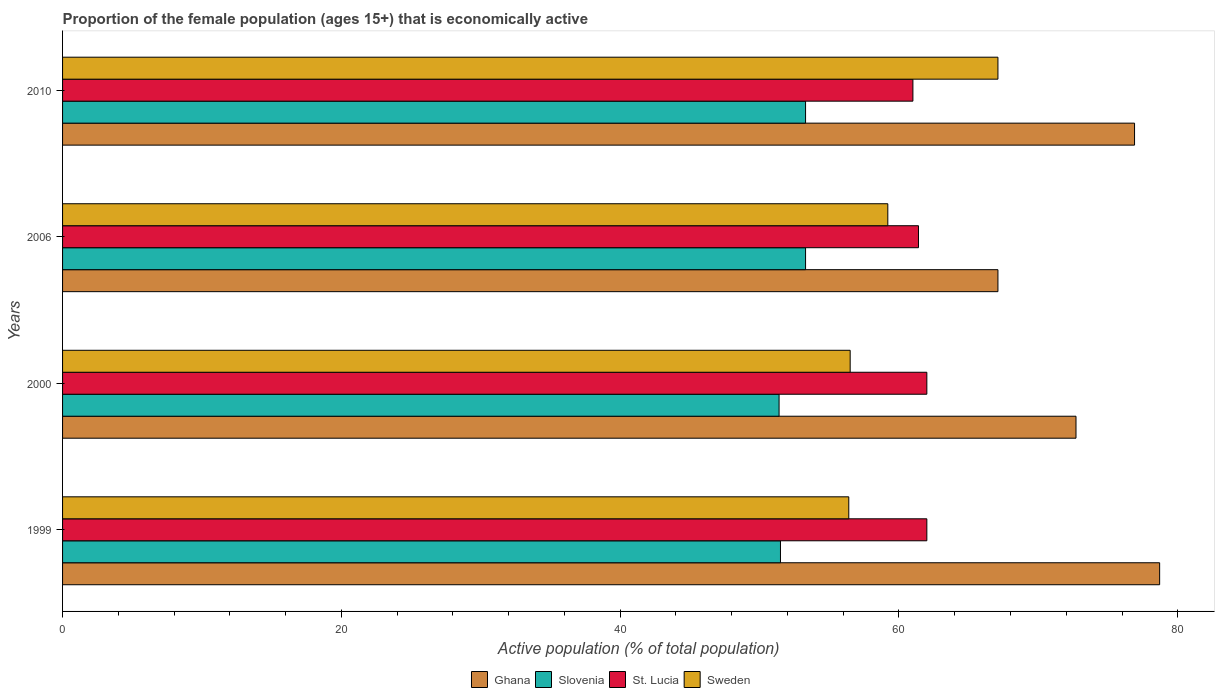How many different coloured bars are there?
Your answer should be very brief. 4. How many groups of bars are there?
Keep it short and to the point. 4. How many bars are there on the 1st tick from the top?
Your answer should be compact. 4. Across all years, what is the maximum proportion of the female population that is economically active in Sweden?
Your answer should be very brief. 67.1. Across all years, what is the minimum proportion of the female population that is economically active in Sweden?
Provide a short and direct response. 56.4. In which year was the proportion of the female population that is economically active in Sweden maximum?
Make the answer very short. 2010. In which year was the proportion of the female population that is economically active in Sweden minimum?
Offer a terse response. 1999. What is the total proportion of the female population that is economically active in Ghana in the graph?
Make the answer very short. 295.4. What is the difference between the proportion of the female population that is economically active in Slovenia in 2000 and that in 2010?
Your answer should be very brief. -1.9. What is the difference between the proportion of the female population that is economically active in St. Lucia in 2010 and the proportion of the female population that is economically active in Slovenia in 2000?
Your answer should be compact. 9.6. What is the average proportion of the female population that is economically active in St. Lucia per year?
Offer a very short reply. 61.6. In the year 2006, what is the difference between the proportion of the female population that is economically active in Sweden and proportion of the female population that is economically active in Ghana?
Provide a short and direct response. -7.9. In how many years, is the proportion of the female population that is economically active in Sweden greater than 36 %?
Make the answer very short. 4. What is the ratio of the proportion of the female population that is economically active in Slovenia in 1999 to that in 2000?
Your answer should be compact. 1. Is the proportion of the female population that is economically active in Sweden in 1999 less than that in 2000?
Offer a very short reply. Yes. What is the difference between the highest and the second highest proportion of the female population that is economically active in Slovenia?
Provide a short and direct response. 0. What is the difference between the highest and the lowest proportion of the female population that is economically active in Sweden?
Give a very brief answer. 10.7. In how many years, is the proportion of the female population that is economically active in Sweden greater than the average proportion of the female population that is economically active in Sweden taken over all years?
Your response must be concise. 1. Is it the case that in every year, the sum of the proportion of the female population that is economically active in Sweden and proportion of the female population that is economically active in Slovenia is greater than the sum of proportion of the female population that is economically active in St. Lucia and proportion of the female population that is economically active in Ghana?
Your response must be concise. No. What does the 2nd bar from the bottom in 2006 represents?
Your response must be concise. Slovenia. Are all the bars in the graph horizontal?
Ensure brevity in your answer.  Yes. How many years are there in the graph?
Your response must be concise. 4. What is the difference between two consecutive major ticks on the X-axis?
Offer a very short reply. 20. Are the values on the major ticks of X-axis written in scientific E-notation?
Your answer should be very brief. No. Does the graph contain grids?
Your response must be concise. No. Where does the legend appear in the graph?
Your response must be concise. Bottom center. How many legend labels are there?
Offer a terse response. 4. What is the title of the graph?
Make the answer very short. Proportion of the female population (ages 15+) that is economically active. Does "Macao" appear as one of the legend labels in the graph?
Offer a very short reply. No. What is the label or title of the X-axis?
Your answer should be compact. Active population (% of total population). What is the Active population (% of total population) in Ghana in 1999?
Ensure brevity in your answer.  78.7. What is the Active population (% of total population) in Slovenia in 1999?
Your response must be concise. 51.5. What is the Active population (% of total population) in St. Lucia in 1999?
Offer a terse response. 62. What is the Active population (% of total population) of Sweden in 1999?
Keep it short and to the point. 56.4. What is the Active population (% of total population) of Ghana in 2000?
Offer a terse response. 72.7. What is the Active population (% of total population) of Slovenia in 2000?
Make the answer very short. 51.4. What is the Active population (% of total population) in St. Lucia in 2000?
Make the answer very short. 62. What is the Active population (% of total population) of Sweden in 2000?
Provide a short and direct response. 56.5. What is the Active population (% of total population) in Ghana in 2006?
Give a very brief answer. 67.1. What is the Active population (% of total population) of Slovenia in 2006?
Your answer should be very brief. 53.3. What is the Active population (% of total population) in St. Lucia in 2006?
Offer a terse response. 61.4. What is the Active population (% of total population) of Sweden in 2006?
Your answer should be compact. 59.2. What is the Active population (% of total population) of Ghana in 2010?
Make the answer very short. 76.9. What is the Active population (% of total population) in Slovenia in 2010?
Ensure brevity in your answer.  53.3. What is the Active population (% of total population) in Sweden in 2010?
Offer a terse response. 67.1. Across all years, what is the maximum Active population (% of total population) of Ghana?
Your answer should be compact. 78.7. Across all years, what is the maximum Active population (% of total population) of Slovenia?
Provide a short and direct response. 53.3. Across all years, what is the maximum Active population (% of total population) of St. Lucia?
Make the answer very short. 62. Across all years, what is the maximum Active population (% of total population) of Sweden?
Give a very brief answer. 67.1. Across all years, what is the minimum Active population (% of total population) of Ghana?
Provide a succinct answer. 67.1. Across all years, what is the minimum Active population (% of total population) of Slovenia?
Your answer should be compact. 51.4. Across all years, what is the minimum Active population (% of total population) in St. Lucia?
Your response must be concise. 61. Across all years, what is the minimum Active population (% of total population) of Sweden?
Make the answer very short. 56.4. What is the total Active population (% of total population) in Ghana in the graph?
Offer a very short reply. 295.4. What is the total Active population (% of total population) of Slovenia in the graph?
Ensure brevity in your answer.  209.5. What is the total Active population (% of total population) of St. Lucia in the graph?
Make the answer very short. 246.4. What is the total Active population (% of total population) in Sweden in the graph?
Give a very brief answer. 239.2. What is the difference between the Active population (% of total population) in Ghana in 1999 and that in 2000?
Provide a succinct answer. 6. What is the difference between the Active population (% of total population) in Sweden in 1999 and that in 2000?
Provide a succinct answer. -0.1. What is the difference between the Active population (% of total population) of Sweden in 1999 and that in 2006?
Make the answer very short. -2.8. What is the difference between the Active population (% of total population) in Ghana in 1999 and that in 2010?
Your answer should be very brief. 1.8. What is the difference between the Active population (% of total population) in Slovenia in 1999 and that in 2010?
Offer a very short reply. -1.8. What is the difference between the Active population (% of total population) of Sweden in 1999 and that in 2010?
Make the answer very short. -10.7. What is the difference between the Active population (% of total population) of Slovenia in 2000 and that in 2006?
Your answer should be compact. -1.9. What is the difference between the Active population (% of total population) in Sweden in 2000 and that in 2006?
Provide a short and direct response. -2.7. What is the difference between the Active population (% of total population) of Slovenia in 2000 and that in 2010?
Keep it short and to the point. -1.9. What is the difference between the Active population (% of total population) of Ghana in 2006 and that in 2010?
Your response must be concise. -9.8. What is the difference between the Active population (% of total population) in Slovenia in 2006 and that in 2010?
Keep it short and to the point. 0. What is the difference between the Active population (% of total population) in Ghana in 1999 and the Active population (% of total population) in Slovenia in 2000?
Provide a short and direct response. 27.3. What is the difference between the Active population (% of total population) in Slovenia in 1999 and the Active population (% of total population) in St. Lucia in 2000?
Keep it short and to the point. -10.5. What is the difference between the Active population (% of total population) of Ghana in 1999 and the Active population (% of total population) of Slovenia in 2006?
Make the answer very short. 25.4. What is the difference between the Active population (% of total population) of Ghana in 1999 and the Active population (% of total population) of St. Lucia in 2006?
Keep it short and to the point. 17.3. What is the difference between the Active population (% of total population) in Ghana in 1999 and the Active population (% of total population) in Sweden in 2006?
Your answer should be compact. 19.5. What is the difference between the Active population (% of total population) in Ghana in 1999 and the Active population (% of total population) in Slovenia in 2010?
Provide a short and direct response. 25.4. What is the difference between the Active population (% of total population) in Ghana in 1999 and the Active population (% of total population) in St. Lucia in 2010?
Offer a very short reply. 17.7. What is the difference between the Active population (% of total population) in Slovenia in 1999 and the Active population (% of total population) in St. Lucia in 2010?
Ensure brevity in your answer.  -9.5. What is the difference between the Active population (% of total population) in Slovenia in 1999 and the Active population (% of total population) in Sweden in 2010?
Provide a short and direct response. -15.6. What is the difference between the Active population (% of total population) in St. Lucia in 1999 and the Active population (% of total population) in Sweden in 2010?
Your answer should be compact. -5.1. What is the difference between the Active population (% of total population) in Ghana in 2000 and the Active population (% of total population) in Sweden in 2006?
Make the answer very short. 13.5. What is the difference between the Active population (% of total population) of Slovenia in 2000 and the Active population (% of total population) of St. Lucia in 2010?
Offer a very short reply. -9.6. What is the difference between the Active population (% of total population) of Slovenia in 2000 and the Active population (% of total population) of Sweden in 2010?
Your answer should be very brief. -15.7. What is the difference between the Active population (% of total population) in Ghana in 2006 and the Active population (% of total population) in Slovenia in 2010?
Your answer should be compact. 13.8. What is the difference between the Active population (% of total population) in Ghana in 2006 and the Active population (% of total population) in St. Lucia in 2010?
Provide a short and direct response. 6.1. What is the difference between the Active population (% of total population) in Ghana in 2006 and the Active population (% of total population) in Sweden in 2010?
Make the answer very short. 0. What is the difference between the Active population (% of total population) in Slovenia in 2006 and the Active population (% of total population) in St. Lucia in 2010?
Ensure brevity in your answer.  -7.7. What is the average Active population (% of total population) in Ghana per year?
Make the answer very short. 73.85. What is the average Active population (% of total population) of Slovenia per year?
Provide a short and direct response. 52.38. What is the average Active population (% of total population) in St. Lucia per year?
Your answer should be compact. 61.6. What is the average Active population (% of total population) in Sweden per year?
Offer a very short reply. 59.8. In the year 1999, what is the difference between the Active population (% of total population) of Ghana and Active population (% of total population) of Slovenia?
Ensure brevity in your answer.  27.2. In the year 1999, what is the difference between the Active population (% of total population) in Ghana and Active population (% of total population) in St. Lucia?
Provide a succinct answer. 16.7. In the year 1999, what is the difference between the Active population (% of total population) in Ghana and Active population (% of total population) in Sweden?
Offer a terse response. 22.3. In the year 1999, what is the difference between the Active population (% of total population) of Slovenia and Active population (% of total population) of Sweden?
Your answer should be very brief. -4.9. In the year 2000, what is the difference between the Active population (% of total population) of Ghana and Active population (% of total population) of Slovenia?
Your response must be concise. 21.3. In the year 2000, what is the difference between the Active population (% of total population) of Ghana and Active population (% of total population) of St. Lucia?
Your answer should be very brief. 10.7. In the year 2000, what is the difference between the Active population (% of total population) in Ghana and Active population (% of total population) in Sweden?
Ensure brevity in your answer.  16.2. In the year 2000, what is the difference between the Active population (% of total population) in St. Lucia and Active population (% of total population) in Sweden?
Offer a very short reply. 5.5. In the year 2006, what is the difference between the Active population (% of total population) of Ghana and Active population (% of total population) of Slovenia?
Your answer should be compact. 13.8. In the year 2006, what is the difference between the Active population (% of total population) of Ghana and Active population (% of total population) of St. Lucia?
Your answer should be very brief. 5.7. In the year 2006, what is the difference between the Active population (% of total population) of Ghana and Active population (% of total population) of Sweden?
Your answer should be very brief. 7.9. In the year 2006, what is the difference between the Active population (% of total population) in Slovenia and Active population (% of total population) in St. Lucia?
Provide a succinct answer. -8.1. In the year 2006, what is the difference between the Active population (% of total population) in Slovenia and Active population (% of total population) in Sweden?
Your answer should be very brief. -5.9. In the year 2006, what is the difference between the Active population (% of total population) in St. Lucia and Active population (% of total population) in Sweden?
Make the answer very short. 2.2. In the year 2010, what is the difference between the Active population (% of total population) in Ghana and Active population (% of total population) in Slovenia?
Your answer should be compact. 23.6. In the year 2010, what is the difference between the Active population (% of total population) in Ghana and Active population (% of total population) in St. Lucia?
Ensure brevity in your answer.  15.9. In the year 2010, what is the difference between the Active population (% of total population) in Slovenia and Active population (% of total population) in St. Lucia?
Make the answer very short. -7.7. In the year 2010, what is the difference between the Active population (% of total population) of Slovenia and Active population (% of total population) of Sweden?
Offer a terse response. -13.8. What is the ratio of the Active population (% of total population) of Ghana in 1999 to that in 2000?
Your response must be concise. 1.08. What is the ratio of the Active population (% of total population) in Sweden in 1999 to that in 2000?
Offer a terse response. 1. What is the ratio of the Active population (% of total population) of Ghana in 1999 to that in 2006?
Give a very brief answer. 1.17. What is the ratio of the Active population (% of total population) in Slovenia in 1999 to that in 2006?
Your answer should be very brief. 0.97. What is the ratio of the Active population (% of total population) of St. Lucia in 1999 to that in 2006?
Make the answer very short. 1.01. What is the ratio of the Active population (% of total population) of Sweden in 1999 to that in 2006?
Your response must be concise. 0.95. What is the ratio of the Active population (% of total population) of Ghana in 1999 to that in 2010?
Offer a terse response. 1.02. What is the ratio of the Active population (% of total population) of Slovenia in 1999 to that in 2010?
Your response must be concise. 0.97. What is the ratio of the Active population (% of total population) in St. Lucia in 1999 to that in 2010?
Your response must be concise. 1.02. What is the ratio of the Active population (% of total population) of Sweden in 1999 to that in 2010?
Your answer should be compact. 0.84. What is the ratio of the Active population (% of total population) of Ghana in 2000 to that in 2006?
Make the answer very short. 1.08. What is the ratio of the Active population (% of total population) in Slovenia in 2000 to that in 2006?
Your answer should be compact. 0.96. What is the ratio of the Active population (% of total population) of St. Lucia in 2000 to that in 2006?
Your response must be concise. 1.01. What is the ratio of the Active population (% of total population) in Sweden in 2000 to that in 2006?
Offer a terse response. 0.95. What is the ratio of the Active population (% of total population) in Ghana in 2000 to that in 2010?
Keep it short and to the point. 0.95. What is the ratio of the Active population (% of total population) in Slovenia in 2000 to that in 2010?
Offer a very short reply. 0.96. What is the ratio of the Active population (% of total population) of St. Lucia in 2000 to that in 2010?
Your answer should be very brief. 1.02. What is the ratio of the Active population (% of total population) of Sweden in 2000 to that in 2010?
Your response must be concise. 0.84. What is the ratio of the Active population (% of total population) in Ghana in 2006 to that in 2010?
Keep it short and to the point. 0.87. What is the ratio of the Active population (% of total population) of Slovenia in 2006 to that in 2010?
Ensure brevity in your answer.  1. What is the ratio of the Active population (% of total population) in St. Lucia in 2006 to that in 2010?
Keep it short and to the point. 1.01. What is the ratio of the Active population (% of total population) of Sweden in 2006 to that in 2010?
Keep it short and to the point. 0.88. What is the difference between the highest and the second highest Active population (% of total population) in St. Lucia?
Your answer should be very brief. 0. What is the difference between the highest and the lowest Active population (% of total population) in St. Lucia?
Provide a short and direct response. 1. What is the difference between the highest and the lowest Active population (% of total population) in Sweden?
Ensure brevity in your answer.  10.7. 